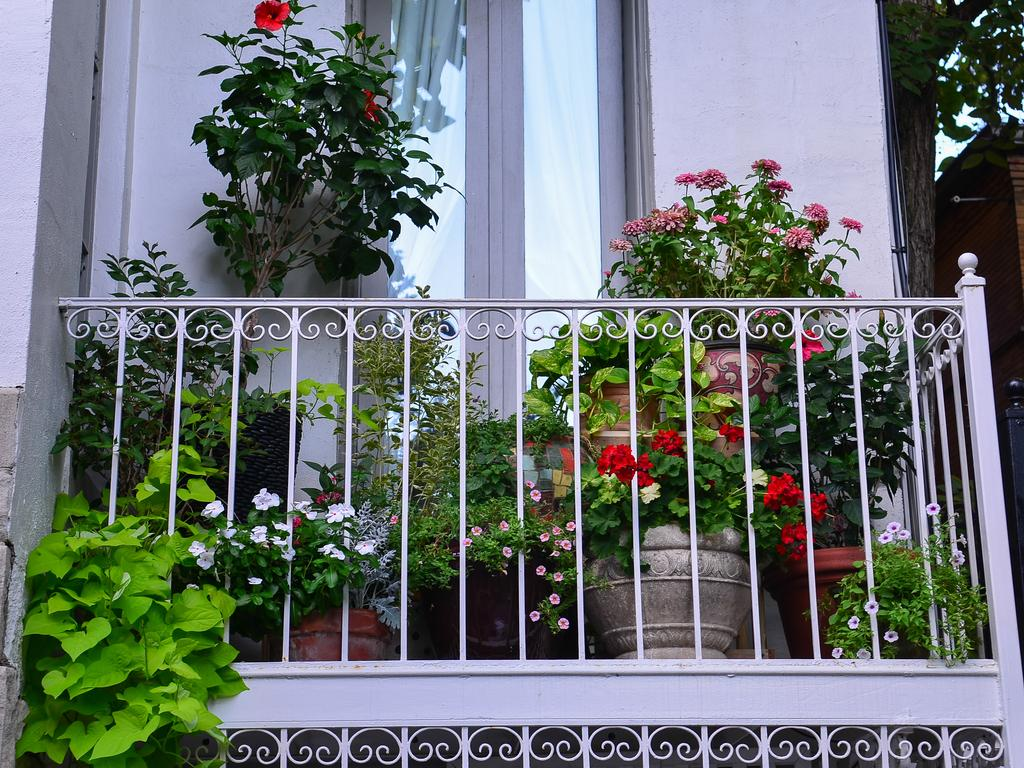What type of structure is present in the image? There is a building in the image. What natural element can be seen in the image? There is a tree in the image. What type of plants are in the image? There are plants in pots with flowers in the image. What architectural feature is visible in the image? There is a window in the image. What type of barrier is present in the image? There is a metal fence in the image. What flavor of oil is being used to comb the tree in the image? There is no oil or combing activity present in the image; it features a building, a tree, plants in pots, a window, and a metal fence. 